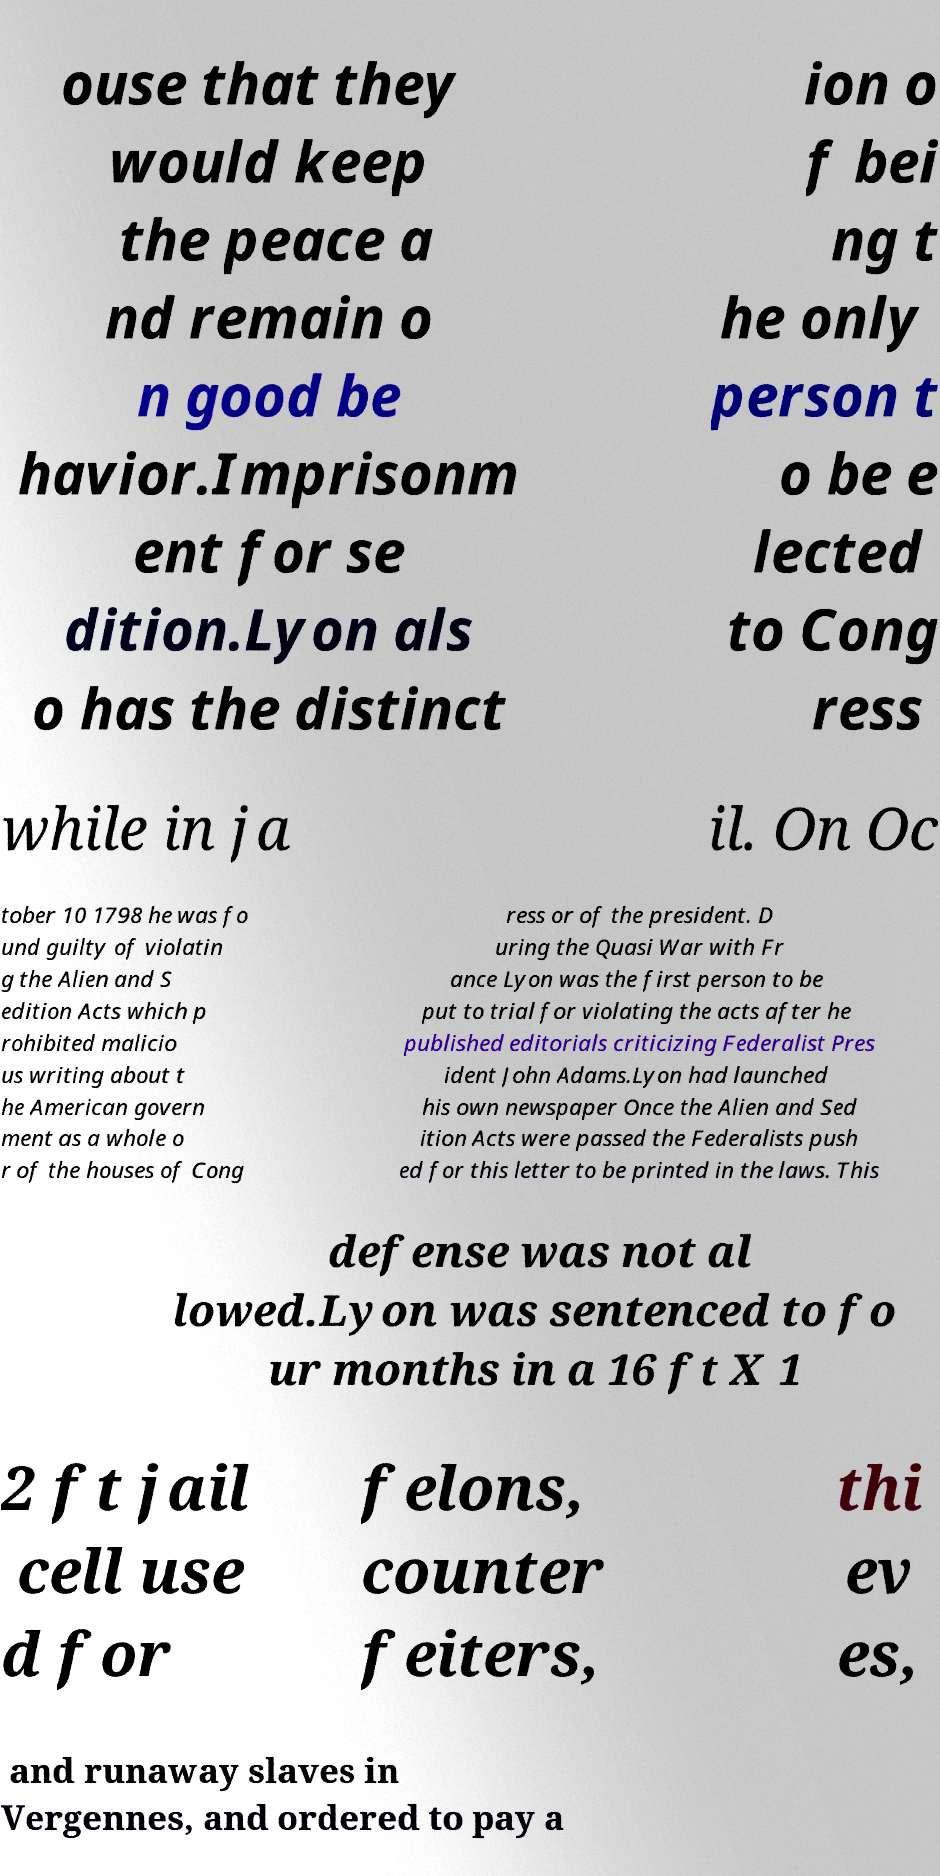Please read and relay the text visible in this image. What does it say? ouse that they would keep the peace a nd remain o n good be havior.Imprisonm ent for se dition.Lyon als o has the distinct ion o f bei ng t he only person t o be e lected to Cong ress while in ja il. On Oc tober 10 1798 he was fo und guilty of violatin g the Alien and S edition Acts which p rohibited malicio us writing about t he American govern ment as a whole o r of the houses of Cong ress or of the president. D uring the Quasi War with Fr ance Lyon was the first person to be put to trial for violating the acts after he published editorials criticizing Federalist Pres ident John Adams.Lyon had launched his own newspaper Once the Alien and Sed ition Acts were passed the Federalists push ed for this letter to be printed in the laws. This defense was not al lowed.Lyon was sentenced to fo ur months in a 16 ft X 1 2 ft jail cell use d for felons, counter feiters, thi ev es, and runaway slaves in Vergennes, and ordered to pay a 